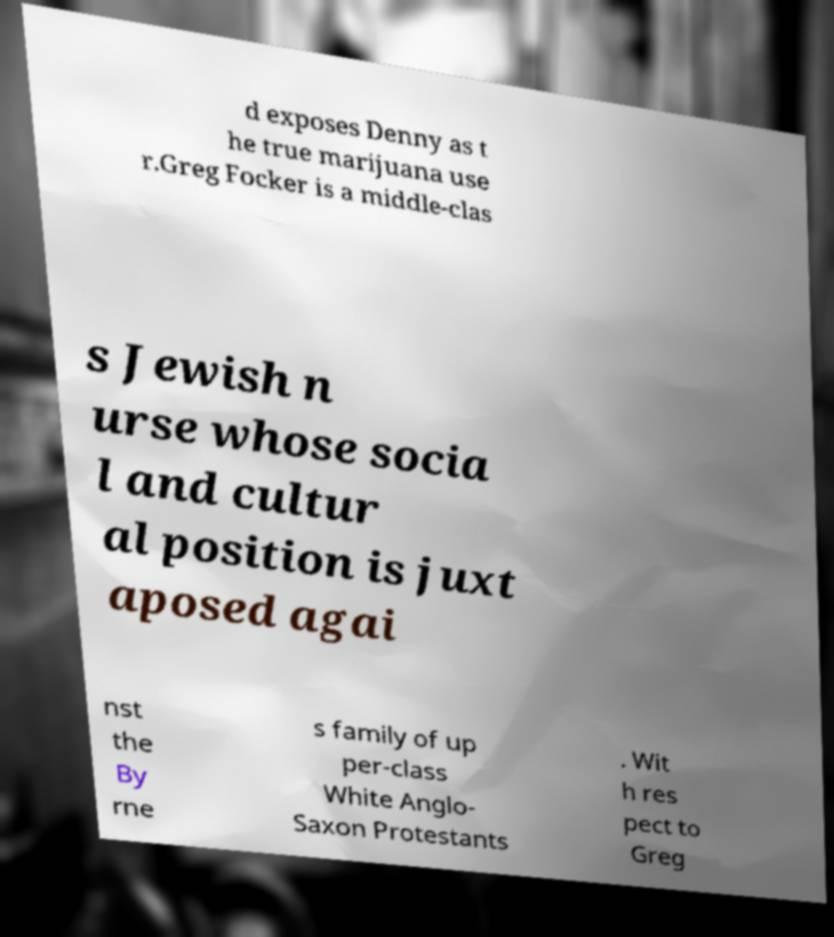Please identify and transcribe the text found in this image. d exposes Denny as t he true marijuana use r.Greg Focker is a middle-clas s Jewish n urse whose socia l and cultur al position is juxt aposed agai nst the By rne s family of up per-class White Anglo- Saxon Protestants . Wit h res pect to Greg 